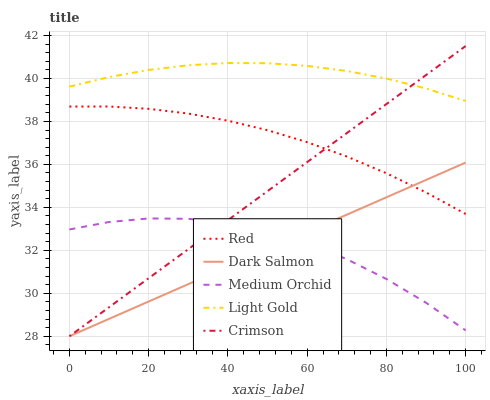Does Dark Salmon have the minimum area under the curve?
Answer yes or no. Yes. Does Light Gold have the maximum area under the curve?
Answer yes or no. Yes. Does Medium Orchid have the minimum area under the curve?
Answer yes or no. No. Does Medium Orchid have the maximum area under the curve?
Answer yes or no. No. Is Crimson the smoothest?
Answer yes or no. Yes. Is Medium Orchid the roughest?
Answer yes or no. Yes. Is Light Gold the smoothest?
Answer yes or no. No. Is Light Gold the roughest?
Answer yes or no. No. Does Crimson have the lowest value?
Answer yes or no. Yes. Does Medium Orchid have the lowest value?
Answer yes or no. No. Does Crimson have the highest value?
Answer yes or no. Yes. Does Light Gold have the highest value?
Answer yes or no. No. Is Red less than Light Gold?
Answer yes or no. Yes. Is Red greater than Medium Orchid?
Answer yes or no. Yes. Does Crimson intersect Dark Salmon?
Answer yes or no. Yes. Is Crimson less than Dark Salmon?
Answer yes or no. No. Is Crimson greater than Dark Salmon?
Answer yes or no. No. Does Red intersect Light Gold?
Answer yes or no. No. 